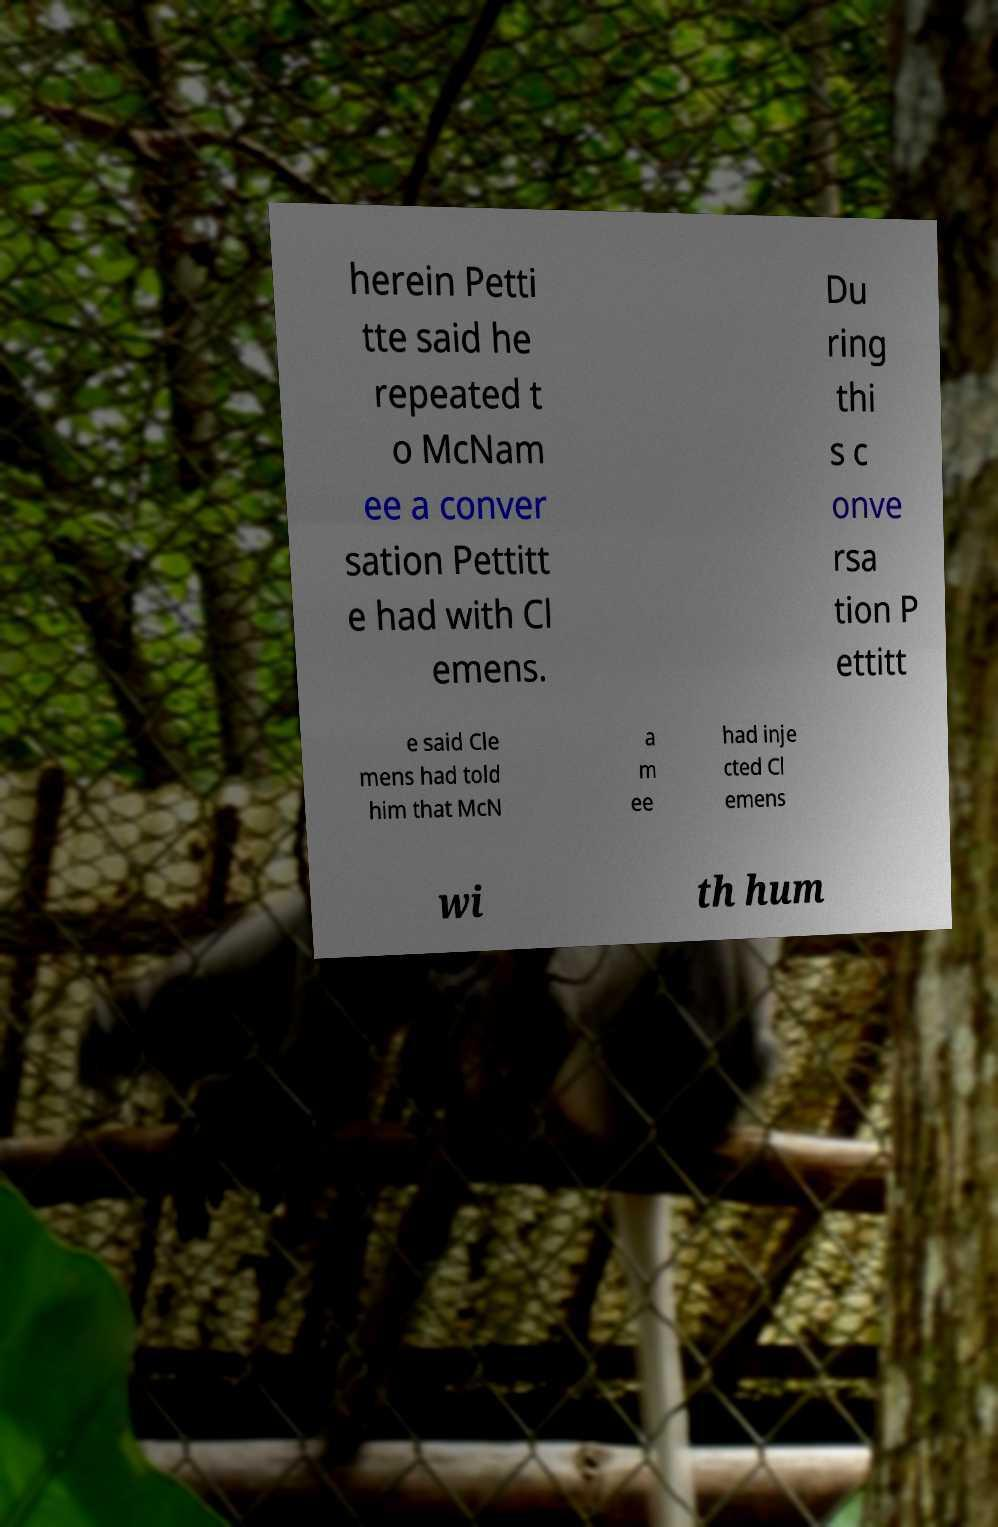There's text embedded in this image that I need extracted. Can you transcribe it verbatim? herein Petti tte said he repeated t o McNam ee a conver sation Pettitt e had with Cl emens. Du ring thi s c onve rsa tion P ettitt e said Cle mens had told him that McN a m ee had inje cted Cl emens wi th hum 